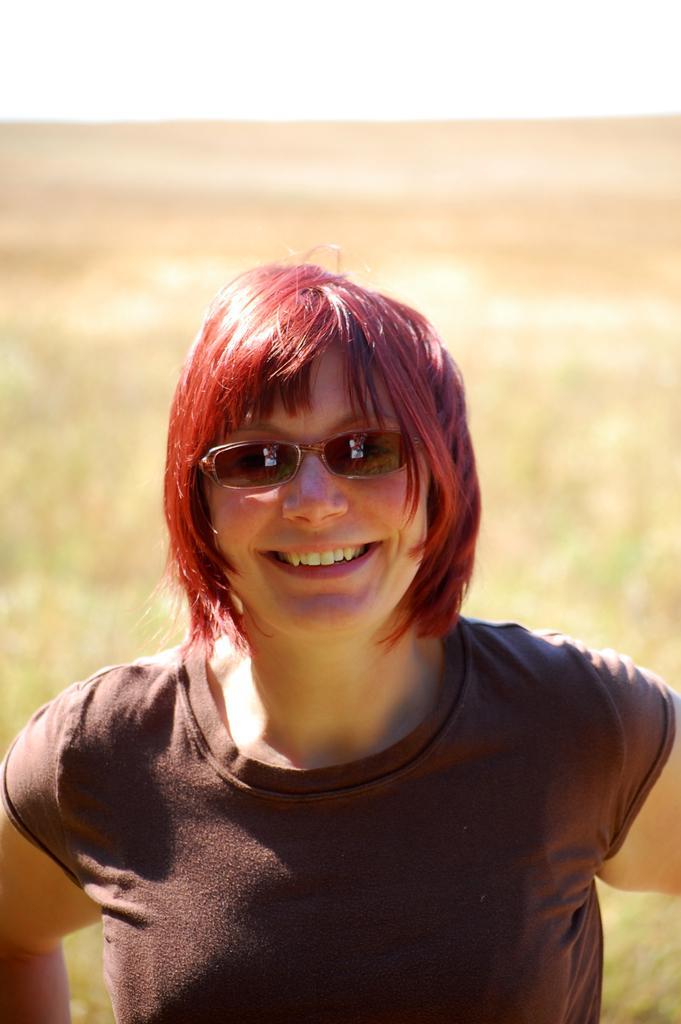Could you give a brief overview of what you see in this image? In this image I can see a woman is wearing t-shirt, smiling and giving pose for the picture. In the background I can see the land. 